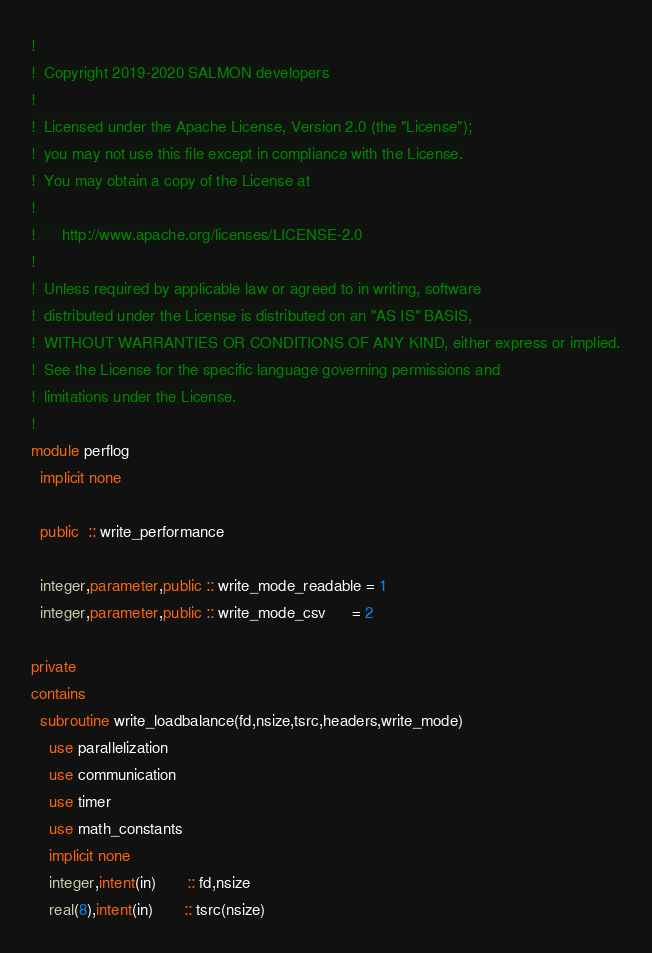<code> <loc_0><loc_0><loc_500><loc_500><_FORTRAN_>!
!  Copyright 2019-2020 SALMON developers
!
!  Licensed under the Apache License, Version 2.0 (the "License");
!  you may not use this file except in compliance with the License.
!  You may obtain a copy of the License at
!
!      http://www.apache.org/licenses/LICENSE-2.0
!
!  Unless required by applicable law or agreed to in writing, software
!  distributed under the License is distributed on an "AS IS" BASIS,
!  WITHOUT WARRANTIES OR CONDITIONS OF ANY KIND, either express or implied.
!  See the License for the specific language governing permissions and
!  limitations under the License.
!
module perflog
  implicit none

  public  :: write_performance

  integer,parameter,public :: write_mode_readable = 1
  integer,parameter,public :: write_mode_csv      = 2

private
contains
  subroutine write_loadbalance(fd,nsize,tsrc,headers,write_mode)
    use parallelization
    use communication
    use timer
    use math_constants
    implicit none
    integer,intent(in)       :: fd,nsize
    real(8),intent(in)       :: tsrc(nsize)</code> 